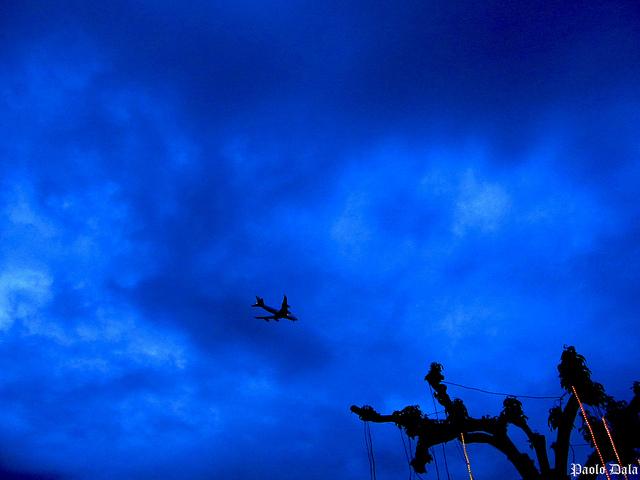Was this taken from an airplane?
Concise answer only. No. Is this an ocean or a lake?
Answer briefly. Lake. Is this outdoors?
Write a very short answer. Yes. What is the dominant color of this picture?
Quick response, please. Blue. What category of objects is pictures?
Concise answer only. Plane. Is it spring?
Be succinct. No. Does this scene take place during the day or at night?
Keep it brief. Night. How many birds are in the air?
Quick response, please. 0. What color is the sky?
Keep it brief. Blue. How many airplanes are there?
Answer briefly. 1. Why is the sky so blue?
Quick response, please. Dusk. Is it a bird or a plane?
Answer briefly. Plane. 